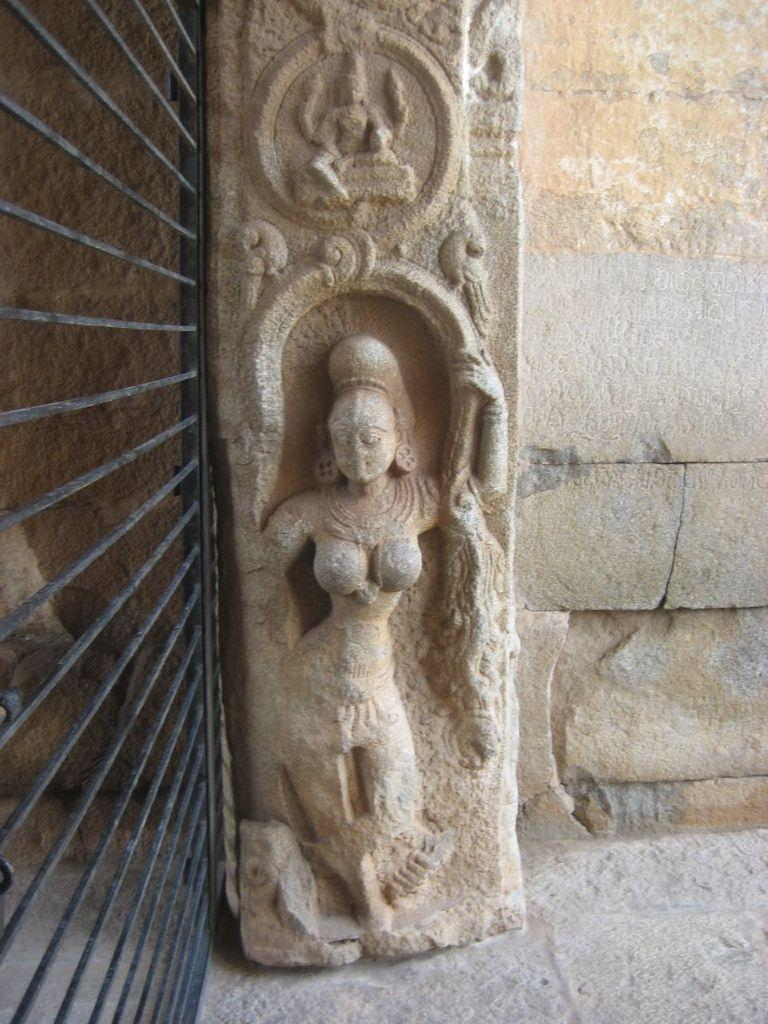What is depicted on the stone wall in the image? There is a carving of a woman on a stone wall in the image. What can be seen on the left side of the image? There is a black color gate on the left side of the image. What color is the stone wall in the image? The wall is in cream color. What type of winter clothing is the aunt wearing in the image? There is no aunt or winter clothing present in the image; it features a carving of a woman on a stone wall and a black color gate. What is the woman using to eat her food in the image? There is no fork or food present in the image; it only shows a carving of a woman on a stone wall and a black color gate. 